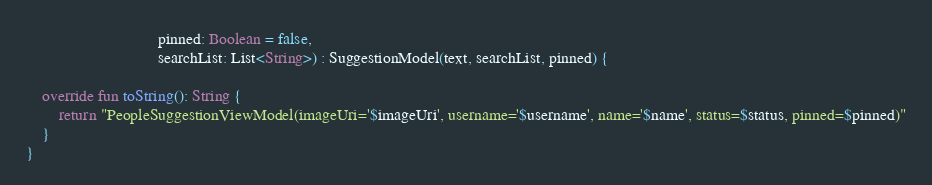Convert code to text. <code><loc_0><loc_0><loc_500><loc_500><_Kotlin_>                                pinned: Boolean = false,
                                searchList: List<String>) : SuggestionModel(text, searchList, pinned) {

    override fun toString(): String {
        return "PeopleSuggestionViewModel(imageUri='$imageUri', username='$username', name='$name', status=$status, pinned=$pinned)"
    }
}</code> 